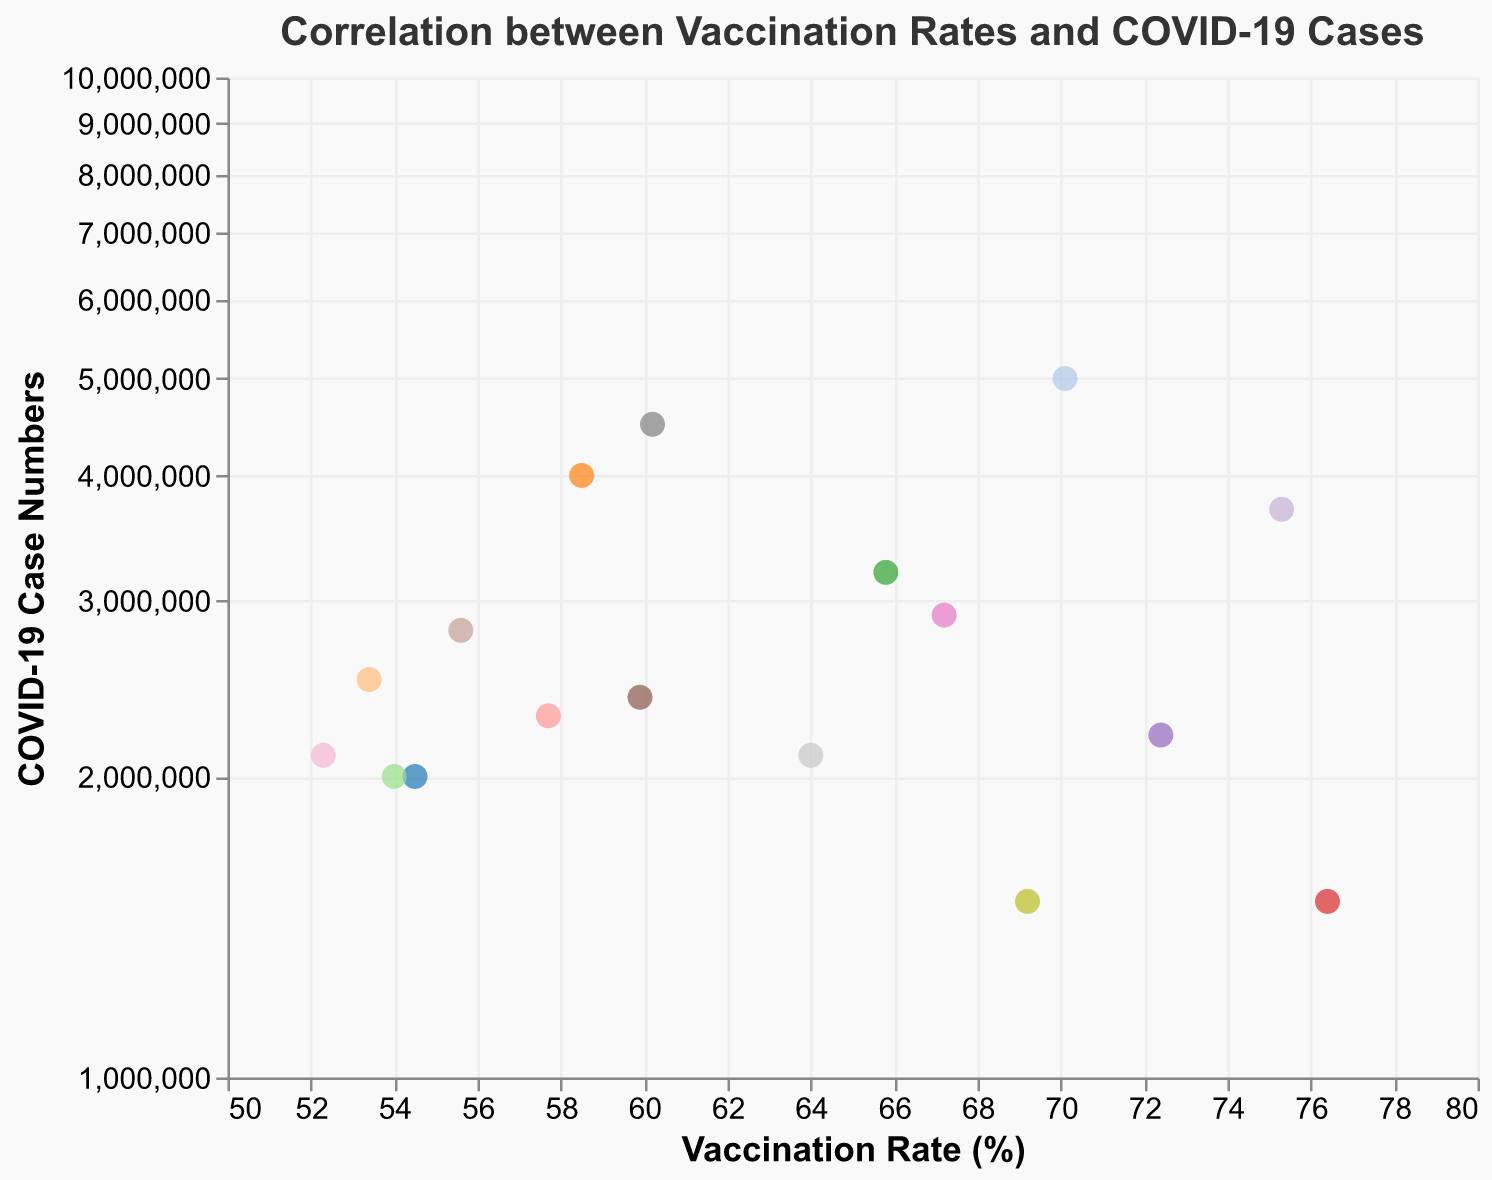How many states have a vaccination rate above 70%? By looking at the x-axis, we can spot the data points that lie to the right of the 70% marker. California, New York, New Jersey, and Massachusetts meet this criterion.
Answer: 4 Which state has the highest number of COVID-19 cases and what is its vaccination rate? By identifying the highest data point on the y-axis, we see California has the highest number of cases at 5,000,000. Its vaccination rate is approximately 70.1%.
Answer: California, 70.1% What's the median vaccination rate of all the states? By arranging the vaccination rates in ascending order (52.3, 53.4, 54.0, 54.5, 55.6, 57.7, 58.5, 59.9, 60.2, 64.0, 65.8, 67.2, 69.2, 70.1, 72.4, 75.3, 76.4), and finding the middle value, we see the median rate. Since there are 17 values, the median is the 9th value: 60.2%.
Answer: 60.2% Which state has a higher vaccination rate: Arizona or Indiana? Comparing the x-axis positions, Indiana is slightly to the left of Arizona. Indiana's rate is 54.0%, and Arizona's rate is 54.5%. Therefore, Arizona has a higher vaccination rate.
Answer: Arizona Is there an observable correlation between vaccination rates and COVID-19 case numbers? There appears to be a trend where states with higher vaccination rates tend to have lower numbers of COVID-19 cases, observable as points move left and down (lower cases) along the y-axis.
Answer: Yes, there seems to be a negative correlation What is the difference in COVID-19 case numbers between New York and Texas? New York has approximately 3,700,000 cases, and Texas has around 4,500,000 cases. Subtracting these values gives 4,500,000 - 3,700,000.
Answer: 800,000 Which state has the lowest number of COVID-19 cases and what is its vaccination rate? By identifying the lowest data point on the y-axis, Massachusetts and Washington both have the lowest number of cases around 1,500,000. Their vaccination rates are 76.4% and 69.2%, respectively.
Answer: Massachusetts and Washington, 76.4% and 69.2% What is the average vaccination rate among the states with COVID-19 case numbers above 3,000,000? States meeting this criterion are California (70.1%), Texas (60.2%), Florida (58.5%), New York (75.3%), and Illinois (65.8%). Summing these rates gives 70.1 + 60.2 + 58.5 + 75.3 + 65.8 = 329.9, and dividing by 5 states gives 329.9 / 5.
Answer: 65.98% 